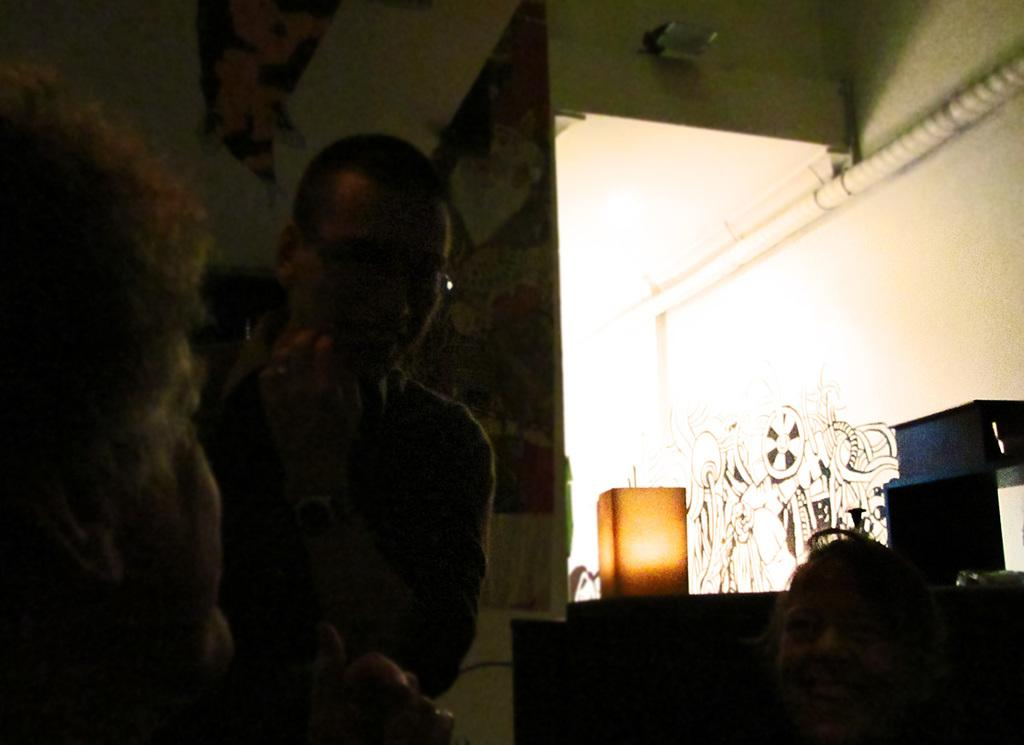How many people are in the image? There are three persons in the image. Can you describe the lighting in the image? Yes, there is light in the image. What other objects can be seen in the image besides the people? There are other objects in the image, but their specific details are not mentioned in the provided facts. What is visible in the background of the image? There is a board and a painting on the walls in the background of the image. What type of celery is being used as a prop in the image? There is no celery present in the image. Can you describe the donkey's reaction to the painting in the background? There is no donkey present in the image, so it is not possible to describe its reaction to the painting. 